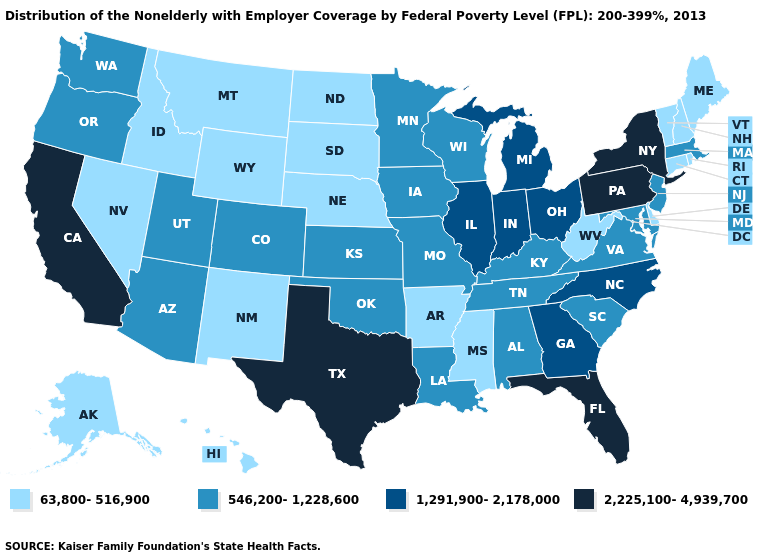Among the states that border Connecticut , which have the lowest value?
Concise answer only. Rhode Island. Name the states that have a value in the range 546,200-1,228,600?
Give a very brief answer. Alabama, Arizona, Colorado, Iowa, Kansas, Kentucky, Louisiana, Maryland, Massachusetts, Minnesota, Missouri, New Jersey, Oklahoma, Oregon, South Carolina, Tennessee, Utah, Virginia, Washington, Wisconsin. What is the value of Alaska?
Give a very brief answer. 63,800-516,900. Which states have the highest value in the USA?
Answer briefly. California, Florida, New York, Pennsylvania, Texas. Name the states that have a value in the range 1,291,900-2,178,000?
Keep it brief. Georgia, Illinois, Indiana, Michigan, North Carolina, Ohio. Name the states that have a value in the range 1,291,900-2,178,000?
Concise answer only. Georgia, Illinois, Indiana, Michigan, North Carolina, Ohio. Name the states that have a value in the range 1,291,900-2,178,000?
Answer briefly. Georgia, Illinois, Indiana, Michigan, North Carolina, Ohio. Does West Virginia have a lower value than Oklahoma?
Concise answer only. Yes. Does Virginia have the highest value in the USA?
Answer briefly. No. Name the states that have a value in the range 63,800-516,900?
Write a very short answer. Alaska, Arkansas, Connecticut, Delaware, Hawaii, Idaho, Maine, Mississippi, Montana, Nebraska, Nevada, New Hampshire, New Mexico, North Dakota, Rhode Island, South Dakota, Vermont, West Virginia, Wyoming. Which states hav the highest value in the MidWest?
Concise answer only. Illinois, Indiana, Michigan, Ohio. What is the highest value in the West ?
Short answer required. 2,225,100-4,939,700. What is the highest value in the USA?
Quick response, please. 2,225,100-4,939,700. 